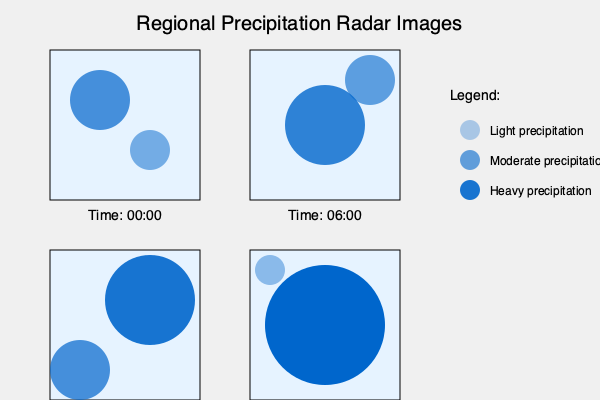Analyze the series of radar images showing precipitation patterns in a region over a 24-hour period. What is the most likely explanation for the observed trend in precipitation intensity and distribution? To answer this question, we need to analyze the radar images step-by-step:

1. Time 00:00:
   - Two small areas of precipitation
   - One moderate (opacity 0.7) and one light (opacity 0.5)
   - Located in the northwest and southeast of the region

2. Time 06:00:
   - Two areas of precipitation have grown and intensified
   - One large area of moderate-heavy precipitation (opacity 0.8)
   - One smaller area of moderate precipitation (opacity 0.6)
   - Precipitation has moved slightly to the east and south

3. Time 12:00:
   - Two distinct areas of precipitation continue to grow and intensify
   - One large area of heavy precipitation (opacity 0.9) in the northeast
   - One moderate-heavy area (opacity 0.7) in the southwest
   - Overall movement towards the east and south continues

4. Time 18:00:
   - One very large area of intense precipitation (opacity 1.0) covering most of the region
   - One small area of light precipitation (opacity 0.4) in the northwest
   - The main precipitation area has expanded and intensified significantly

Analyzing these trends, we can conclude:

1. The precipitation is intensifying over time, with the opacity (representing intensity) increasing from 0.5-0.7 to 1.0.
2. The precipitation areas are merging and expanding, covering more of the region as time progresses.
3. There is a general movement of the precipitation system from northwest to southeast.

These observations are consistent with a typical weather system, such as a warm front or a low-pressure system, moving across the region. As the system progresses, it brings increasingly intense precipitation, expands in area, and moves in a general northwest to southeast direction.

The most likely explanation for this trend is the passage of a developing low-pressure system or warm front, characterized by:
1. Increasing precipitation intensity as the system matures
2. Expanding area of precipitation as the system grows
3. Movement from northwest to southeast, following typical mid-latitude weather patterns
Answer: Passage of a developing low-pressure system or warm front moving southeast 